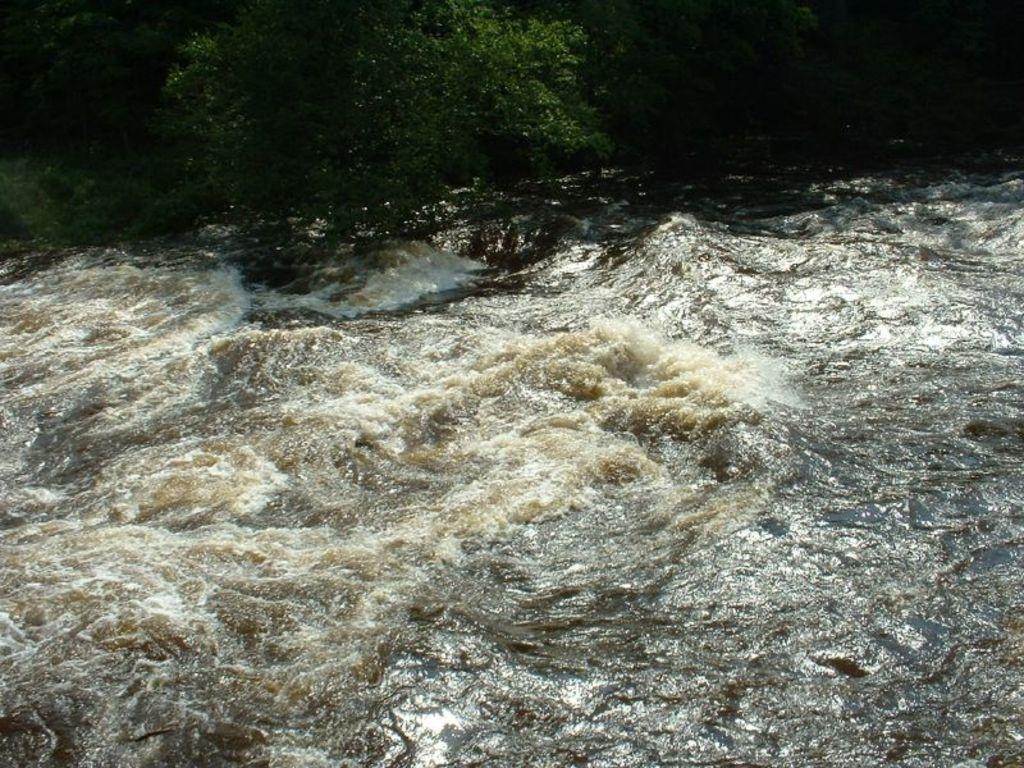What is partially visible in the image? Water is partially visible in the image, truncated towards the bottom. What else is partially visible in the image? Trees are partially visible in the image, truncated towards the top. Where is the turkey playing basketball in the image? There is no turkey or basketball present in the image. 